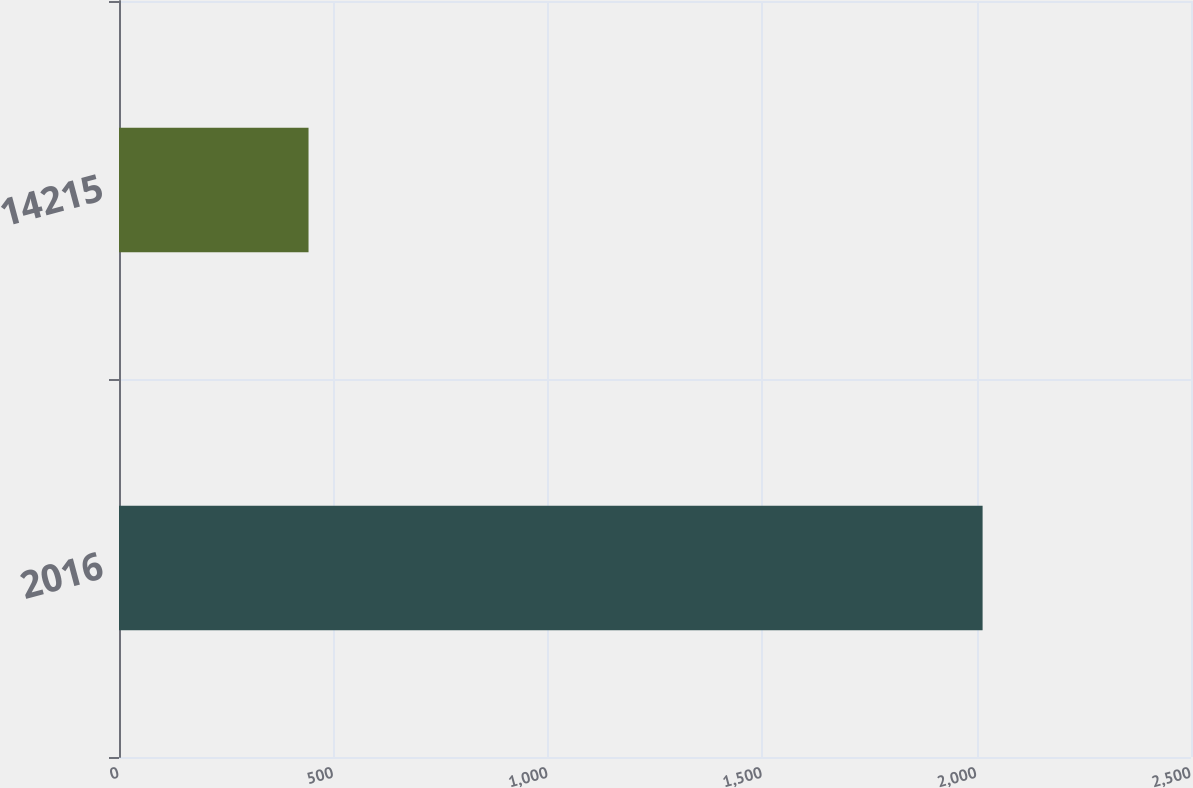Convert chart to OTSL. <chart><loc_0><loc_0><loc_500><loc_500><bar_chart><fcel>2016<fcel>14215<nl><fcel>2014<fcel>442<nl></chart> 